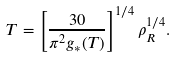<formula> <loc_0><loc_0><loc_500><loc_500>T = \left [ \frac { 3 0 } { \pi ^ { 2 } g _ { * } ( T ) } \right ] ^ { 1 / 4 } \rho _ { R } ^ { 1 / 4 } .</formula> 